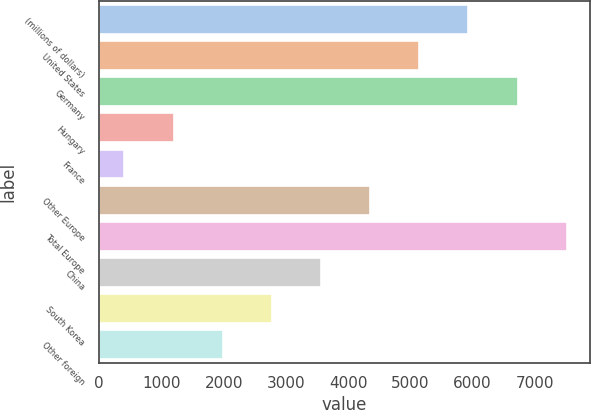Convert chart to OTSL. <chart><loc_0><loc_0><loc_500><loc_500><bar_chart><fcel>(millions of dollars)<fcel>United States<fcel>Germany<fcel>Hungary<fcel>France<fcel>Other Europe<fcel>Total Europe<fcel>China<fcel>South Korea<fcel>Other foreign<nl><fcel>5935.13<fcel>5145.14<fcel>6725.12<fcel>1195.19<fcel>405.2<fcel>4355.15<fcel>7515.11<fcel>3565.16<fcel>2775.17<fcel>1985.18<nl></chart> 